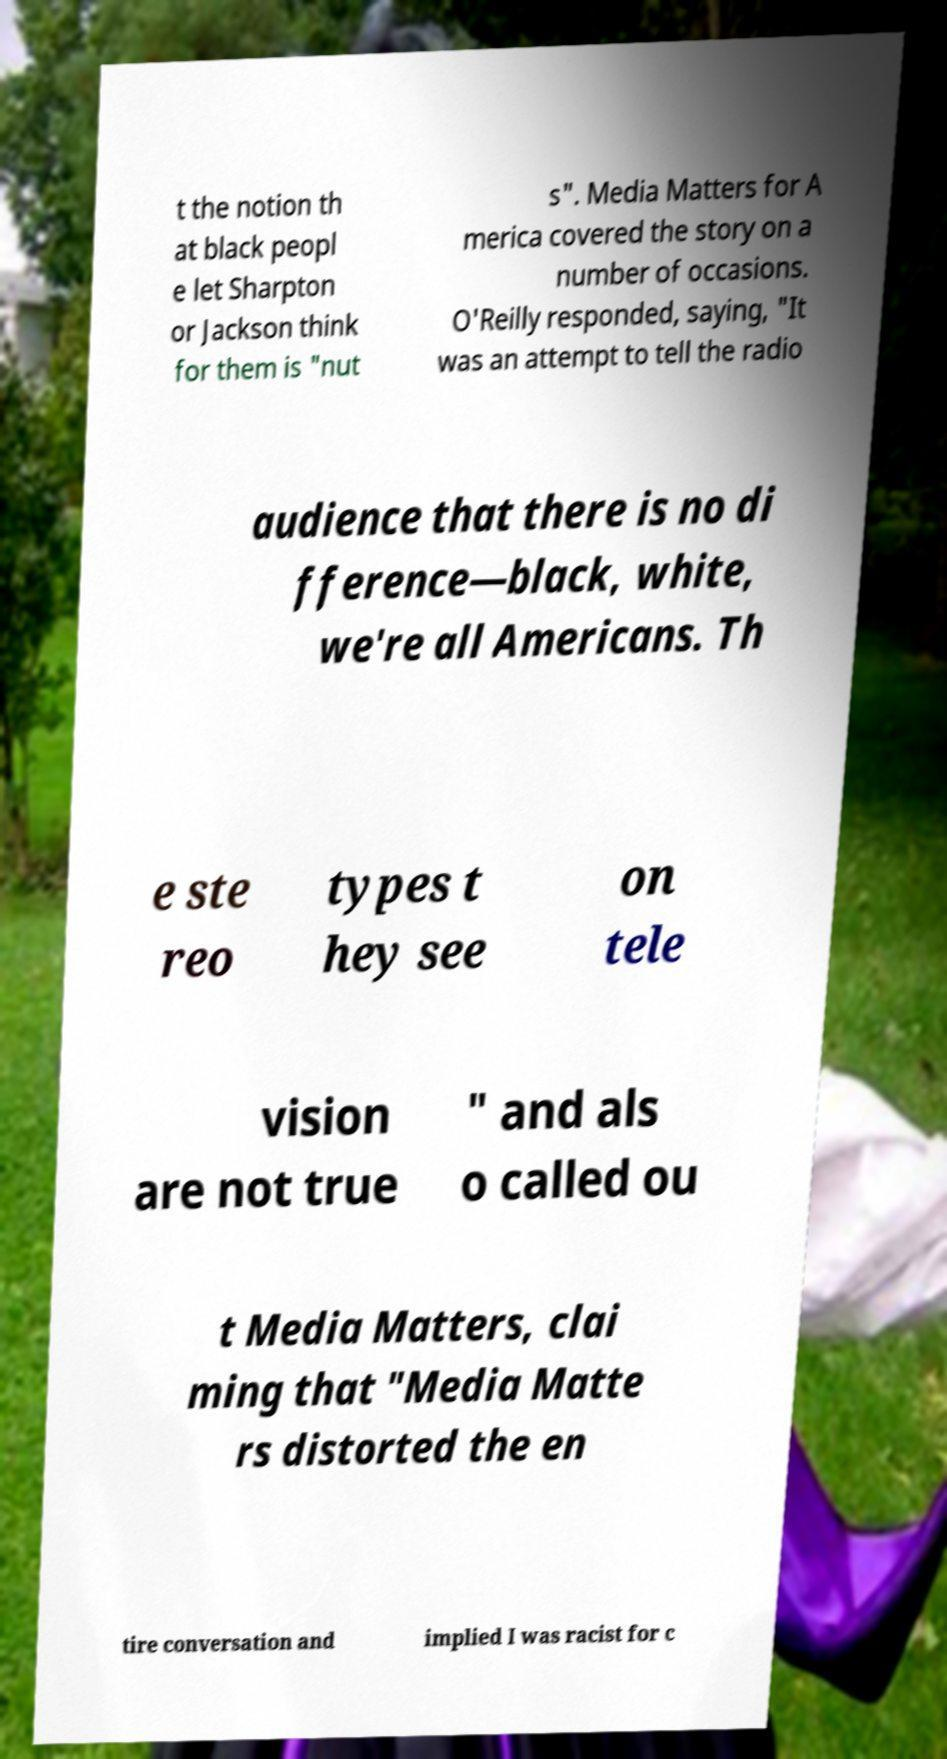What messages or text are displayed in this image? I need them in a readable, typed format. t the notion th at black peopl e let Sharpton or Jackson think for them is "nut s". Media Matters for A merica covered the story on a number of occasions. O'Reilly responded, saying, "It was an attempt to tell the radio audience that there is no di fference—black, white, we're all Americans. Th e ste reo types t hey see on tele vision are not true " and als o called ou t Media Matters, clai ming that "Media Matte rs distorted the en tire conversation and implied I was racist for c 